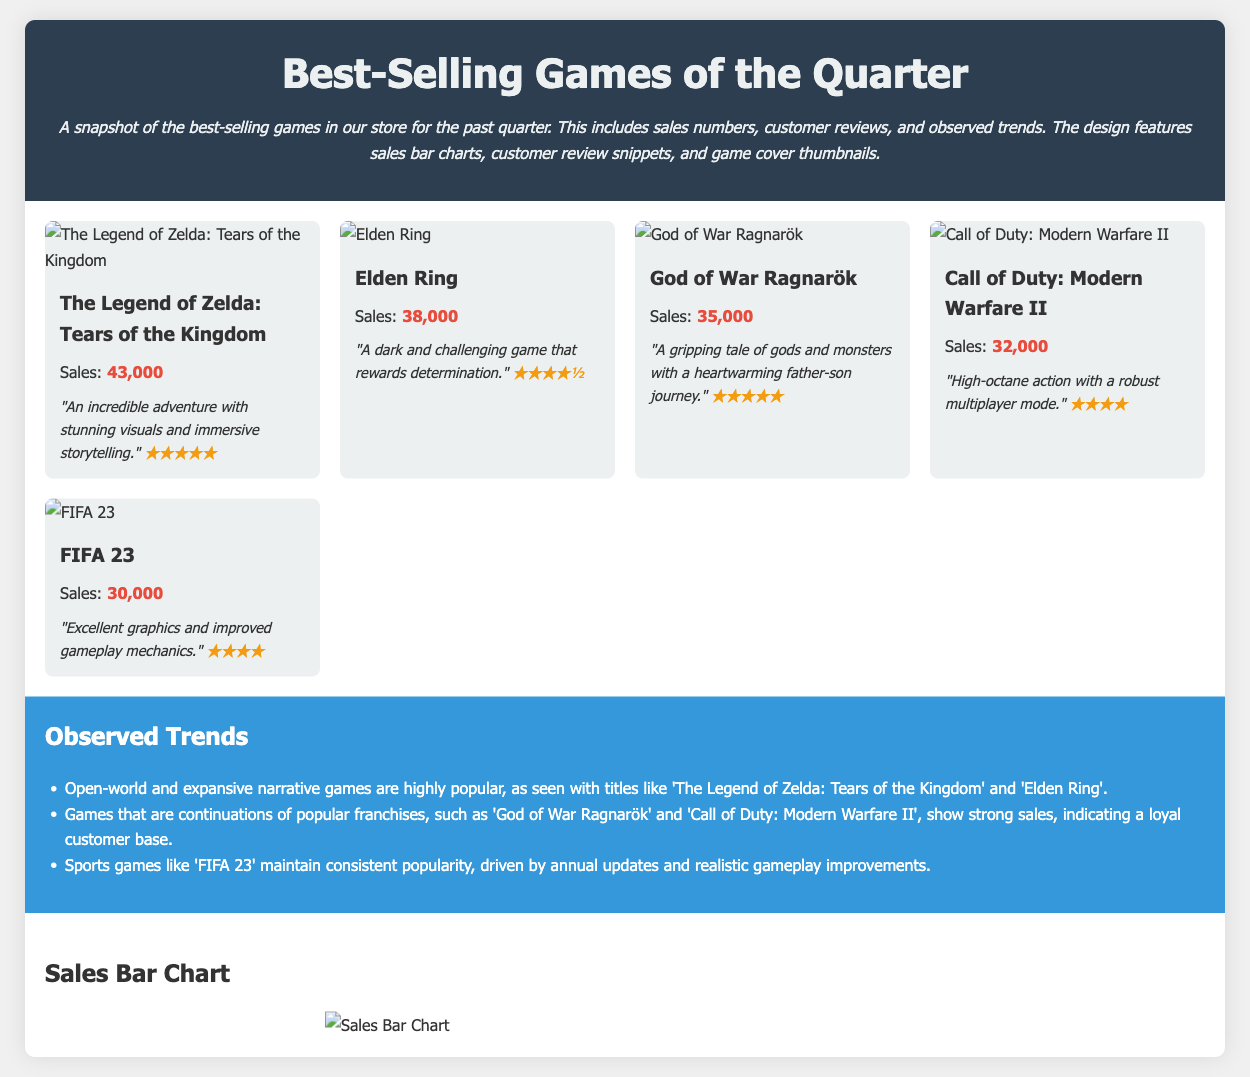What is the best-selling game this quarter? The best-selling game this quarter is listed first in the document as "The Legend of Zelda: Tears of the Kingdom."
Answer: The Legend of Zelda: Tears of the Kingdom How many sales did Elden Ring achieve? The detailed sales number for Elden Ring is mentioned in the game card section.
Answer: 38,000 What review rating did God of War Ragnarök receive? The review rating for God of War Ragnarök is displayed in stars in the review section of the game card.
Answer: ★★★★★ Which game had the lowest sales numbers? The game with the lowest sales number is identified by comparing sales figures of all listed games.
Answer: FIFA 23 What trend is observed regarding open-world games? The document highlights that open-world games are trending based on the popularity of specific titles.
Answer: Highly popular What is the total number of sales for Call of Duty: Modern Warfare II? The total sales number for Call of Duty: Modern Warfare II is explicitly stated in the game card.
Answer: 32,000 How many games have a customer review rating of five stars? The document lists the games with their ratings, allowing for a count of those rated five stars.
Answer: 2 Which game features high-octane action? The description in the review section of Call of Duty: Modern Warfare II points out its action style.
Answer: Call of Duty: Modern Warfare II What type of games maintains consistent popularity? The document states a specific genre that remains popular, referring to sports games.
Answer: Sports games 